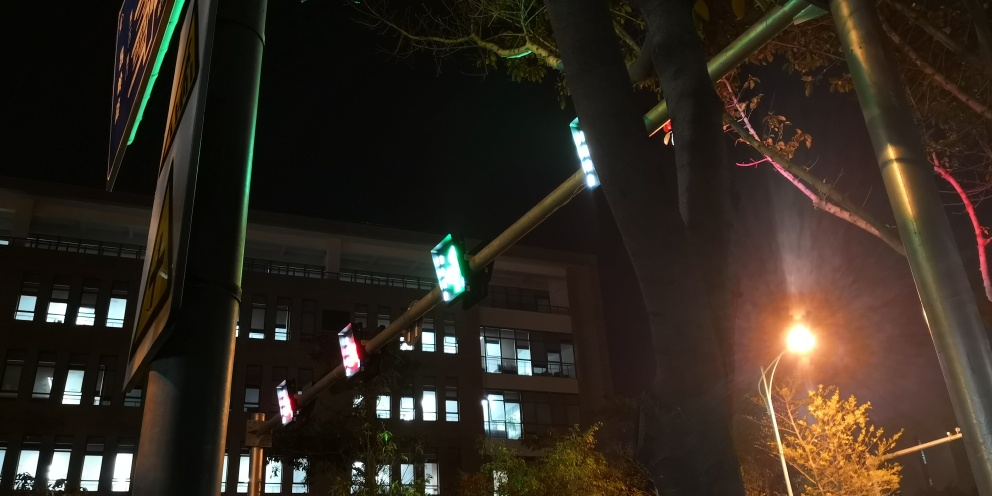What atmosphere or mood does the image convey? The image conveys a quiet, still atmosphere, possibly late at night when city activity has dwindled. The cool hues of the lights against the backdrop of a building add to the serene urban ambiance of the scene. Can you speculate about the location or setting based on the details in the image? The presence of traffic signals and street lights suggests an urban setting, likely within a city. The style of the building and the infrastructure might indicate a modern metropolitan area, although the precise location cannot be determined from this image alone. 